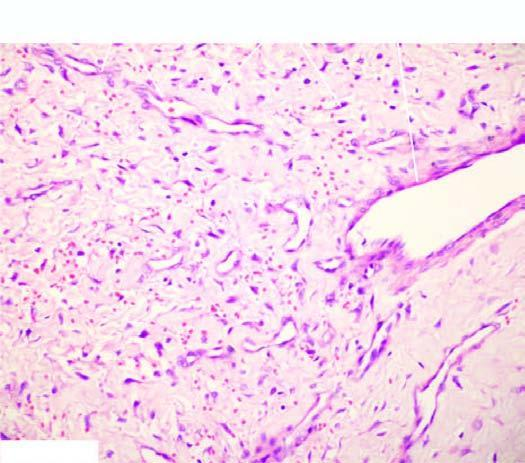what have incomplete muscle coat?
Answer the question using a single word or phrase. Some blood vessels 